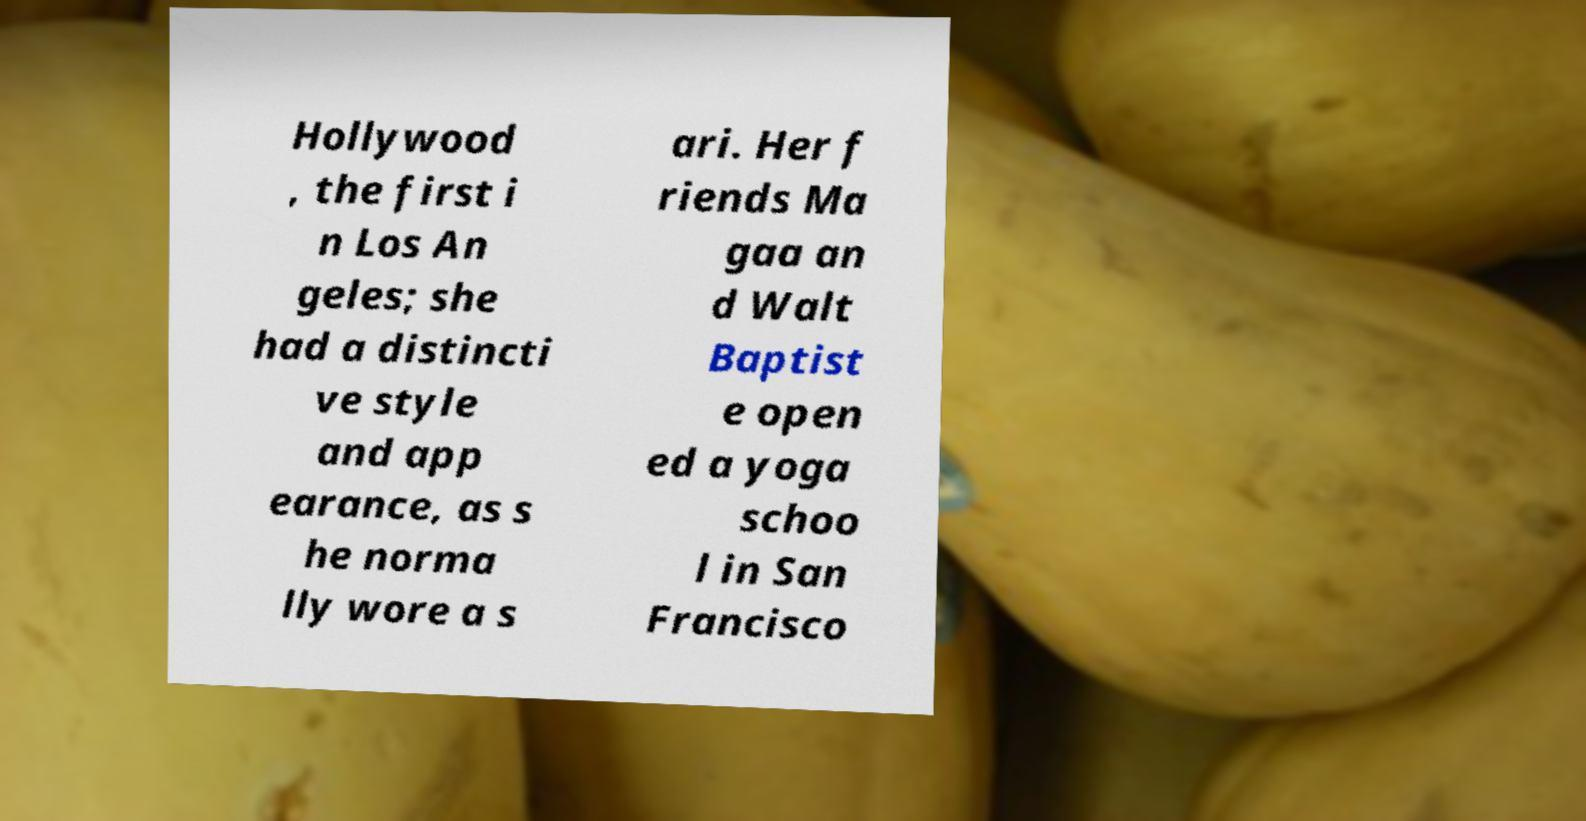What messages or text are displayed in this image? I need them in a readable, typed format. Hollywood , the first i n Los An geles; she had a distincti ve style and app earance, as s he norma lly wore a s ari. Her f riends Ma gaa an d Walt Baptist e open ed a yoga schoo l in San Francisco 